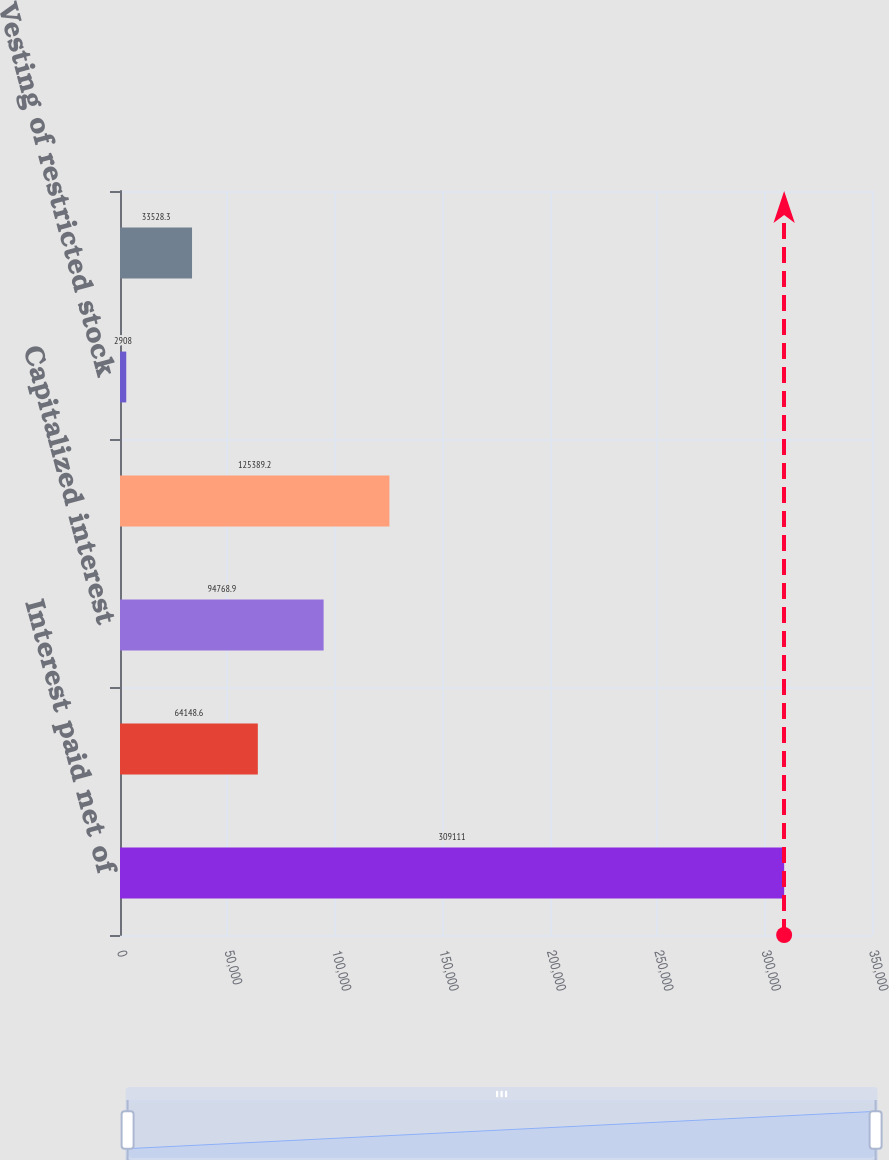<chart> <loc_0><loc_0><loc_500><loc_500><bar_chart><fcel>Interest paid net of<fcel>Income taxes paid<fcel>Capitalized interest<fcel>Accrued construction costs<fcel>Vesting of restricted stock<fcel>Mortgages and other<nl><fcel>309111<fcel>64148.6<fcel>94768.9<fcel>125389<fcel>2908<fcel>33528.3<nl></chart> 